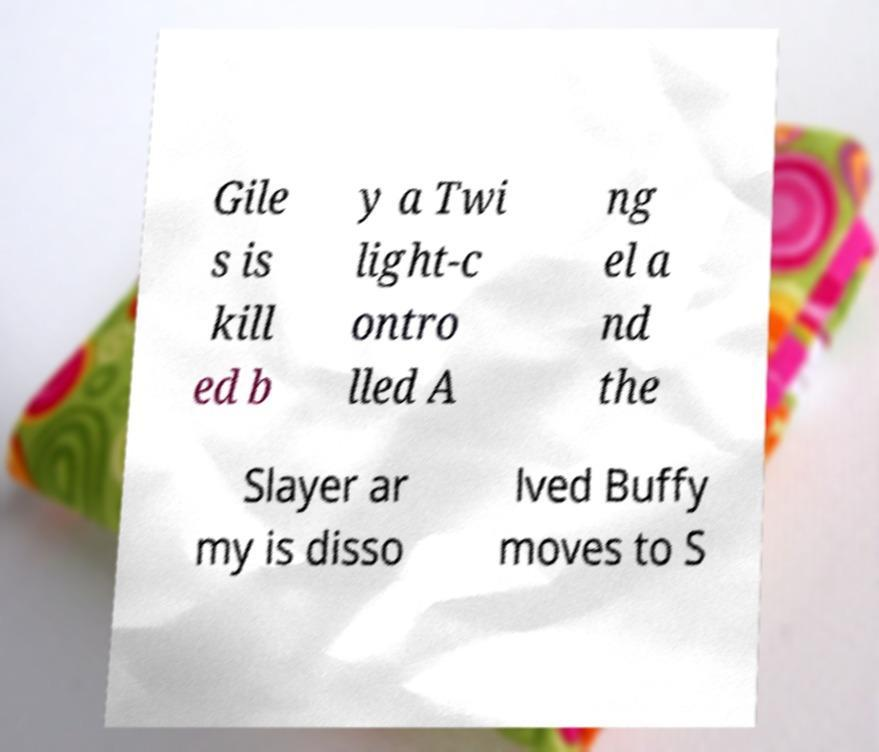Please read and relay the text visible in this image. What does it say? Gile s is kill ed b y a Twi light-c ontro lled A ng el a nd the Slayer ar my is disso lved Buffy moves to S 